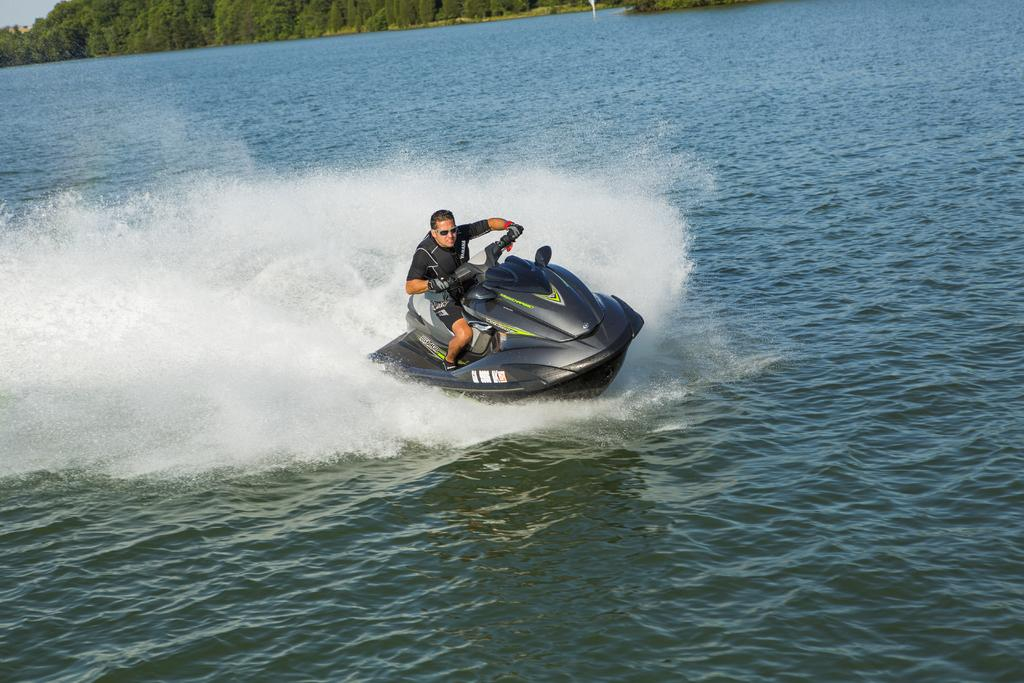Who is in the image? There is a man in the image. What is the man doing in the image? The man is riding a jet ski in the image. Where is the jet ski located? The jet ski is on water in the image. What can be seen in the background of the image? There are trees and the sky visible in the background of the image. What type of wool is being used to create a field in the image? There is no wool or field present in the image; it features a man riding a jet ski on water with trees and the sky in the background. 